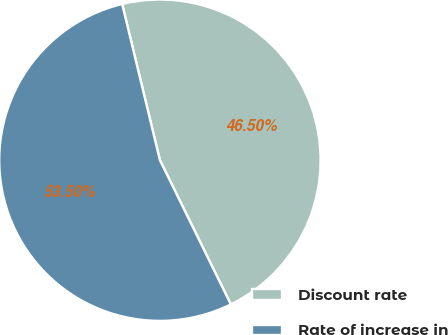Convert chart to OTSL. <chart><loc_0><loc_0><loc_500><loc_500><pie_chart><fcel>Discount rate<fcel>Rate of increase in<nl><fcel>46.5%<fcel>53.5%<nl></chart> 